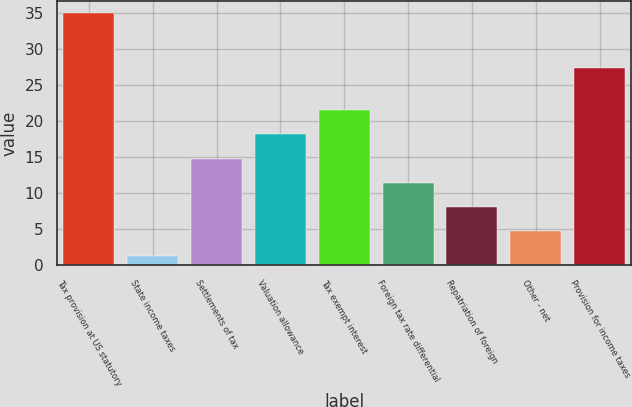Convert chart. <chart><loc_0><loc_0><loc_500><loc_500><bar_chart><fcel>Tax provision at US statutory<fcel>State income taxes<fcel>Settlements of tax<fcel>Valuation allowance<fcel>Tax exempt interest<fcel>Foreign tax rate differential<fcel>Repatriation of foreign<fcel>Other - net<fcel>Provision for income taxes<nl><fcel>35<fcel>1.3<fcel>14.78<fcel>18.15<fcel>21.52<fcel>11.41<fcel>8.04<fcel>4.67<fcel>27.4<nl></chart> 